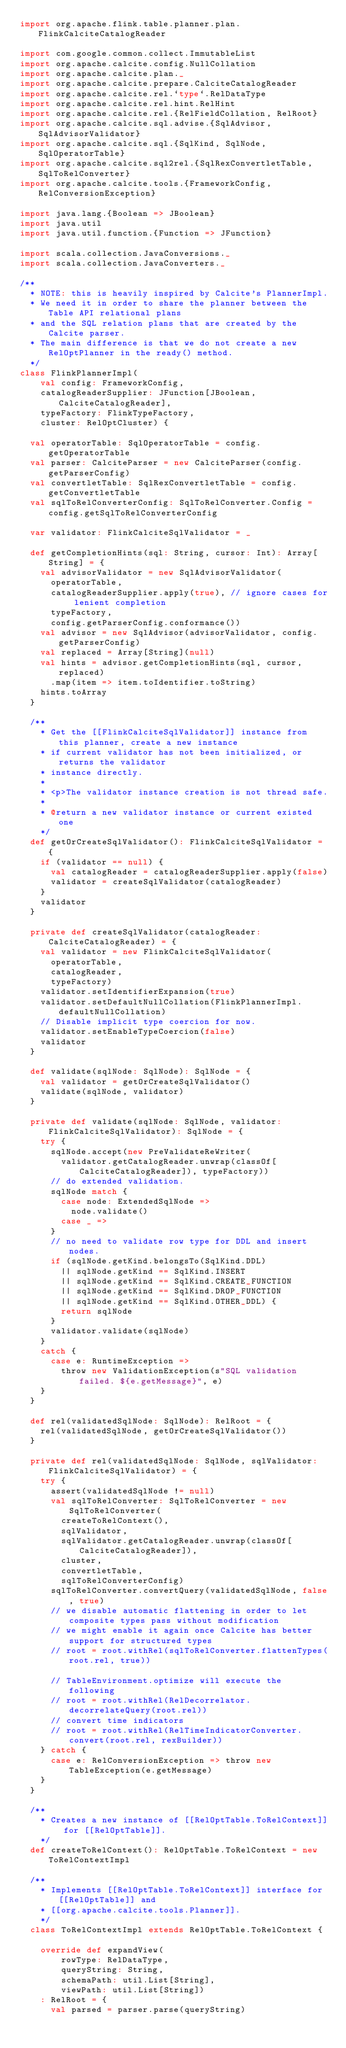<code> <loc_0><loc_0><loc_500><loc_500><_Scala_>import org.apache.flink.table.planner.plan.FlinkCalciteCatalogReader

import com.google.common.collect.ImmutableList
import org.apache.calcite.config.NullCollation
import org.apache.calcite.plan._
import org.apache.calcite.prepare.CalciteCatalogReader
import org.apache.calcite.rel.`type`.RelDataType
import org.apache.calcite.rel.hint.RelHint
import org.apache.calcite.rel.{RelFieldCollation, RelRoot}
import org.apache.calcite.sql.advise.{SqlAdvisor, SqlAdvisorValidator}
import org.apache.calcite.sql.{SqlKind, SqlNode, SqlOperatorTable}
import org.apache.calcite.sql2rel.{SqlRexConvertletTable, SqlToRelConverter}
import org.apache.calcite.tools.{FrameworkConfig, RelConversionException}

import java.lang.{Boolean => JBoolean}
import java.util
import java.util.function.{Function => JFunction}

import scala.collection.JavaConversions._
import scala.collection.JavaConverters._

/**
  * NOTE: this is heavily inspired by Calcite's PlannerImpl.
  * We need it in order to share the planner between the Table API relational plans
  * and the SQL relation plans that are created by the Calcite parser.
  * The main difference is that we do not create a new RelOptPlanner in the ready() method.
  */
class FlinkPlannerImpl(
    val config: FrameworkConfig,
    catalogReaderSupplier: JFunction[JBoolean, CalciteCatalogReader],
    typeFactory: FlinkTypeFactory,
    cluster: RelOptCluster) {

  val operatorTable: SqlOperatorTable = config.getOperatorTable
  val parser: CalciteParser = new CalciteParser(config.getParserConfig)
  val convertletTable: SqlRexConvertletTable = config.getConvertletTable
  val sqlToRelConverterConfig: SqlToRelConverter.Config = config.getSqlToRelConverterConfig

  var validator: FlinkCalciteSqlValidator = _

  def getCompletionHints(sql: String, cursor: Int): Array[String] = {
    val advisorValidator = new SqlAdvisorValidator(
      operatorTable,
      catalogReaderSupplier.apply(true), // ignore cases for lenient completion
      typeFactory,
      config.getParserConfig.conformance())
    val advisor = new SqlAdvisor(advisorValidator, config.getParserConfig)
    val replaced = Array[String](null)
    val hints = advisor.getCompletionHints(sql, cursor, replaced)
      .map(item => item.toIdentifier.toString)
    hints.toArray
  }

  /**
    * Get the [[FlinkCalciteSqlValidator]] instance from this planner, create a new instance
    * if current validator has not been initialized, or returns the validator
    * instance directly.
    *
    * <p>The validator instance creation is not thread safe.
    *
    * @return a new validator instance or current existed one
    */
  def getOrCreateSqlValidator(): FlinkCalciteSqlValidator = {
    if (validator == null) {
      val catalogReader = catalogReaderSupplier.apply(false)
      validator = createSqlValidator(catalogReader)
    }
    validator
  }

  private def createSqlValidator(catalogReader: CalciteCatalogReader) = {
    val validator = new FlinkCalciteSqlValidator(
      operatorTable,
      catalogReader,
      typeFactory)
    validator.setIdentifierExpansion(true)
    validator.setDefaultNullCollation(FlinkPlannerImpl.defaultNullCollation)
    // Disable implicit type coercion for now.
    validator.setEnableTypeCoercion(false)
    validator
  }

  def validate(sqlNode: SqlNode): SqlNode = {
    val validator = getOrCreateSqlValidator()
    validate(sqlNode, validator)
  }

  private def validate(sqlNode: SqlNode, validator: FlinkCalciteSqlValidator): SqlNode = {
    try {
      sqlNode.accept(new PreValidateReWriter(
        validator.getCatalogReader.unwrap(classOf[CalciteCatalogReader]), typeFactory))
      // do extended validation.
      sqlNode match {
        case node: ExtendedSqlNode =>
          node.validate()
        case _ =>
      }
      // no need to validate row type for DDL and insert nodes.
      if (sqlNode.getKind.belongsTo(SqlKind.DDL)
        || sqlNode.getKind == SqlKind.INSERT
        || sqlNode.getKind == SqlKind.CREATE_FUNCTION
        || sqlNode.getKind == SqlKind.DROP_FUNCTION
        || sqlNode.getKind == SqlKind.OTHER_DDL) {
        return sqlNode
      }
      validator.validate(sqlNode)
    }
    catch {
      case e: RuntimeException =>
        throw new ValidationException(s"SQL validation failed. ${e.getMessage}", e)
    }
  }

  def rel(validatedSqlNode: SqlNode): RelRoot = {
    rel(validatedSqlNode, getOrCreateSqlValidator())
  }

  private def rel(validatedSqlNode: SqlNode, sqlValidator: FlinkCalciteSqlValidator) = {
    try {
      assert(validatedSqlNode != null)
      val sqlToRelConverter: SqlToRelConverter = new SqlToRelConverter(
        createToRelContext(),
        sqlValidator,
        sqlValidator.getCatalogReader.unwrap(classOf[CalciteCatalogReader]),
        cluster,
        convertletTable,
        sqlToRelConverterConfig)
      sqlToRelConverter.convertQuery(validatedSqlNode, false, true)
      // we disable automatic flattening in order to let composite types pass without modification
      // we might enable it again once Calcite has better support for structured types
      // root = root.withRel(sqlToRelConverter.flattenTypes(root.rel, true))

      // TableEnvironment.optimize will execute the following
      // root = root.withRel(RelDecorrelator.decorrelateQuery(root.rel))
      // convert time indicators
      // root = root.withRel(RelTimeIndicatorConverter.convert(root.rel, rexBuilder))
    } catch {
      case e: RelConversionException => throw new TableException(e.getMessage)
    }
  }

  /**
    * Creates a new instance of [[RelOptTable.ToRelContext]] for [[RelOptTable]].
    */
  def createToRelContext(): RelOptTable.ToRelContext = new ToRelContextImpl

  /**
    * Implements [[RelOptTable.ToRelContext]] interface for [[RelOptTable]] and
    * [[org.apache.calcite.tools.Planner]].
    */
  class ToRelContextImpl extends RelOptTable.ToRelContext {

    override def expandView(
        rowType: RelDataType,
        queryString: String,
        schemaPath: util.List[String],
        viewPath: util.List[String])
    : RelRoot = {
      val parsed = parser.parse(queryString)</code> 